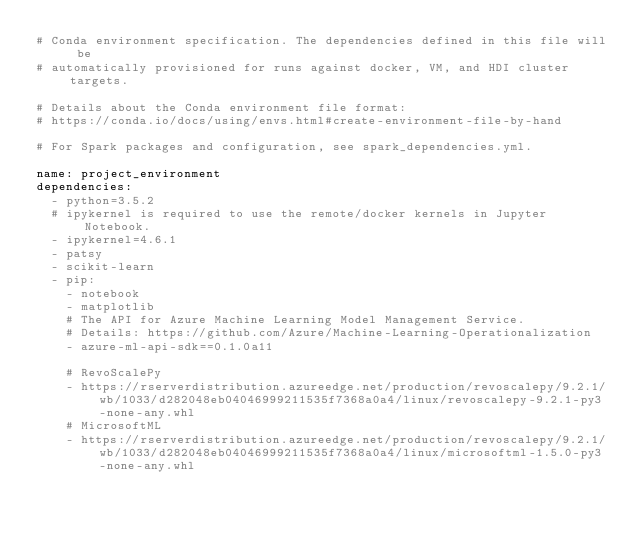<code> <loc_0><loc_0><loc_500><loc_500><_YAML_># Conda environment specification. The dependencies defined in this file will be
# automatically provisioned for runs against docker, VM, and HDI cluster targets.

# Details about the Conda environment file format:
# https://conda.io/docs/using/envs.html#create-environment-file-by-hand

# For Spark packages and configuration, see spark_dependencies.yml.

name: project_environment
dependencies:
  - python=3.5.2
  # ipykernel is required to use the remote/docker kernels in Jupyter Notebook.
  - ipykernel=4.6.1
  - patsy
  - scikit-learn
  - pip:
    - notebook
    - matplotlib
    # The API for Azure Machine Learning Model Management Service.
    # Details: https://github.com/Azure/Machine-Learning-Operationalization
    - azure-ml-api-sdk==0.1.0a11
    
    # RevoScalePy
    - https://rserverdistribution.azureedge.net/production/revoscalepy/9.2.1/wb/1033/d282048eb04046999211535f7368a0a4/linux/revoscalepy-9.2.1-py3-none-any.whl
    # MicrosoftML
    - https://rserverdistribution.azureedge.net/production/revoscalepy/9.2.1/wb/1033/d282048eb04046999211535f7368a0a4/linux/microsoftml-1.5.0-py3-none-any.whl
</code> 